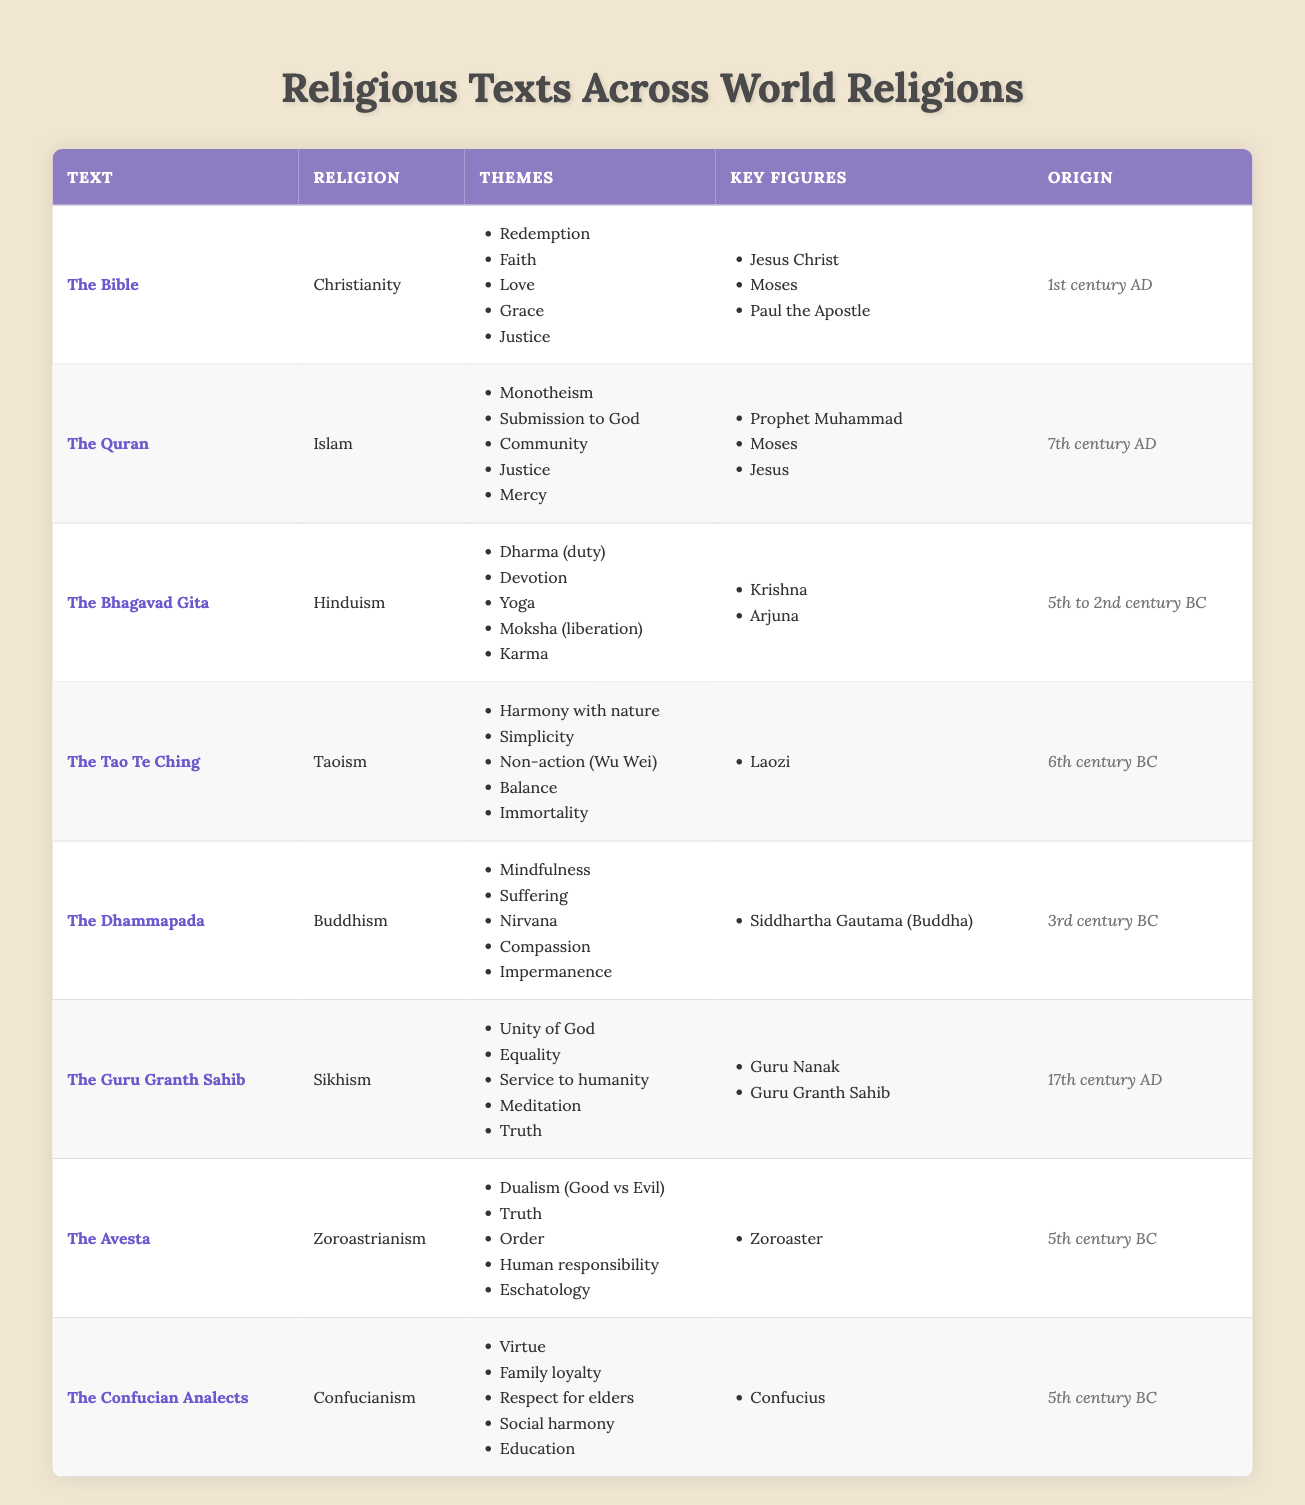What are the main themes found in The Quran? The themes listed for The Quran in the table are: Monotheism, Submission to God, Community, Justice, and Mercy.
Answer: Monotheism, Submission to God, Community, Justice, Mercy How many key figures are mentioned in The Bhagavad Gita? The table shows two key figures associated with The Bhagavad Gita: Krishna and Arjuna. Therefore, the count is 2.
Answer: 2 Which religious text has the theme of "Dualism (Good vs Evil)"? According to the table, the Avesta from Zoroastrianism contains the theme of Dualism (Good vs Evil).
Answer: The Avesta Is compassion a theme in Buddhism? The table lists Compassion as one of the themes of The Dhammapada, which is a Buddhist text; thus, the statement is true.
Answer: Yes Which religion's text originated in the 1st century AD? The table shows that The Bible, associated with Christianity, originated in the 1st century AD.
Answer: Christianity What is the origin of The Guru Granth Sahib? The table indicates that The Guru Granth Sahib originated in the 17th century AD.
Answer: 17th century AD Can you find a common theme in both Christianity and Sikhism? The themes of Justice, found in The Bible, and Truth, found in The Guru Granth Sahib, reflect the pursuit of moral values, indicating a thematic link in both religions.
Answer: Justice, Truth What is the earliest religious text listed in this table? Comparing the origins, The Bhagavad Gita (5th to 2nd century BC) is the earliest text among the ones listed.
Answer: The Bhagavad Gita How many themes does the Tao Te Ching contain, and what is one of them? The Tao Te Ching lists five themes in the table: Harmony with nature, Simplicity, Non-action (Wu Wei), Balance, and Immortality. Thus, the count is 5, and one theme is Harmony with nature.
Answer: 5; one theme: Harmony with nature Which text mentions a key figure named "Siddhartha Gautama"? The Dhammapada mentions Siddhartha Gautama, also known as Buddha, as its key figure.
Answer: The Dhammapada Which religion emphasizes "Service to humanity" according to the table? The Guru Granth Sahib associated with Sikhism lists "Service to humanity" as one of its key themes.
Answer: Sikhism What is a theme that both Hinduism and Buddhism share? Both religions emphasize concepts related to duty and mindfulness, as shown by Dharma in The Bhagavad Gita and the concept of Mindfulness in The Dhammapada.
Answer: Duty, Mindfulness Name two key figures found in Zoroastrianism? The table lists one key figure for Zoroastrianism: Zoroaster. Therefore, the answer is singular as only one key figure is mentioned.
Answer: Zoroaster What is the relationship between the Avesta and the concept of truth? The Avesta includes Truth as one of its themes, indicating that Zoroastrianism values this concept significantly.
Answer: Truth is a theme of the Avesta Does the Confucian Analects contain any themes related to education? Yes, the Confucian Analects explicitly mentions Education as one of its themes in the table.
Answer: Yes 